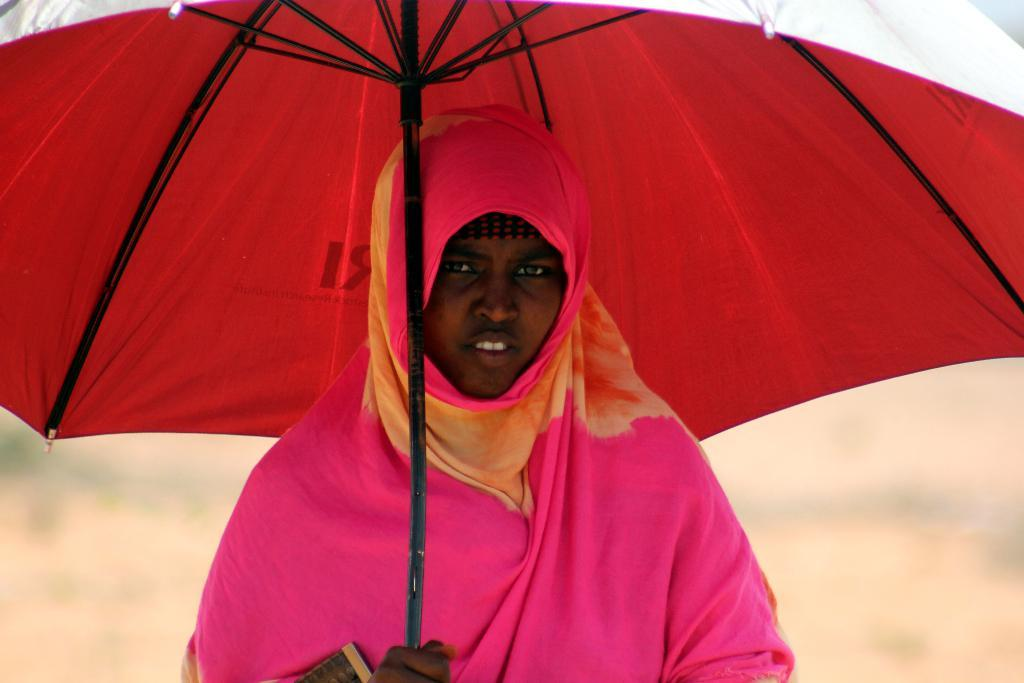What is the lady in the center of the image wearing? The lady is wearing a scarf. What is the lady holding in the image? The lady is holding an umbrella. Can you describe the background of the image? The background of the image is blurry. What type of farm can be seen in the image? There is no farm present in the image; it features a lady wearing a scarf and holding an umbrella. How many units are visible in the image? The provided facts do not mention any units, so it cannot be determined from the image. 